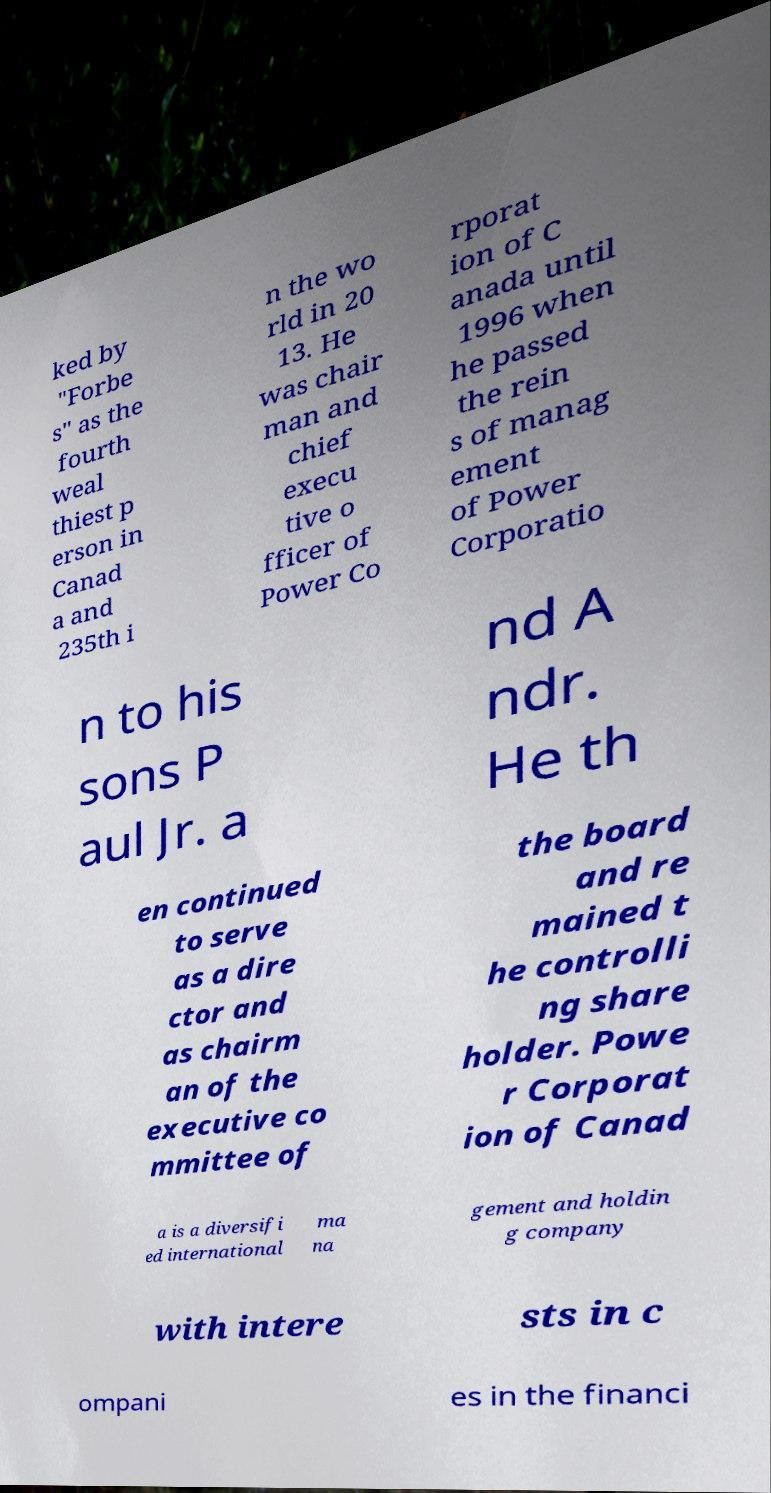Please read and relay the text visible in this image. What does it say? ked by "Forbe s" as the fourth weal thiest p erson in Canad a and 235th i n the wo rld in 20 13. He was chair man and chief execu tive o fficer of Power Co rporat ion of C anada until 1996 when he passed the rein s of manag ement of Power Corporatio n to his sons P aul Jr. a nd A ndr. He th en continued to serve as a dire ctor and as chairm an of the executive co mmittee of the board and re mained t he controlli ng share holder. Powe r Corporat ion of Canad a is a diversifi ed international ma na gement and holdin g company with intere sts in c ompani es in the financi 